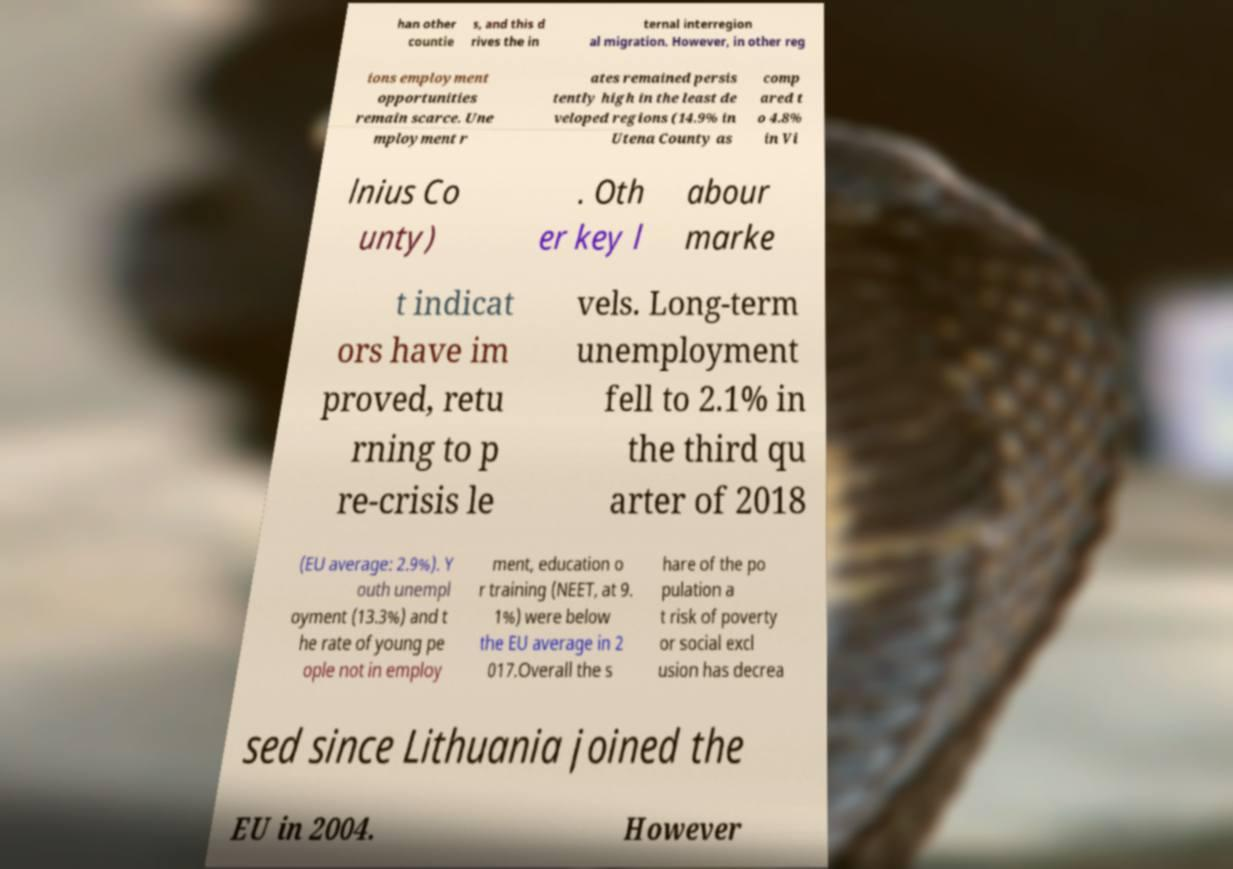Could you assist in decoding the text presented in this image and type it out clearly? han other countie s, and this d rives the in ternal interregion al migration. However, in other reg ions employment opportunities remain scarce. Une mployment r ates remained persis tently high in the least de veloped regions (14.9% in Utena County as comp ared t o 4.8% in Vi lnius Co unty) . Oth er key l abour marke t indicat ors have im proved, retu rning to p re-crisis le vels. Long-term unemployment fell to 2.1% in the third qu arter of 2018 (EU average: 2.9%). Y outh unempl oyment (13.3%) and t he rate of young pe ople not in employ ment, education o r training (NEET, at 9. 1%) were below the EU average in 2 017.Overall the s hare of the po pulation a t risk of poverty or social excl usion has decrea sed since Lithuania joined the EU in 2004. However 